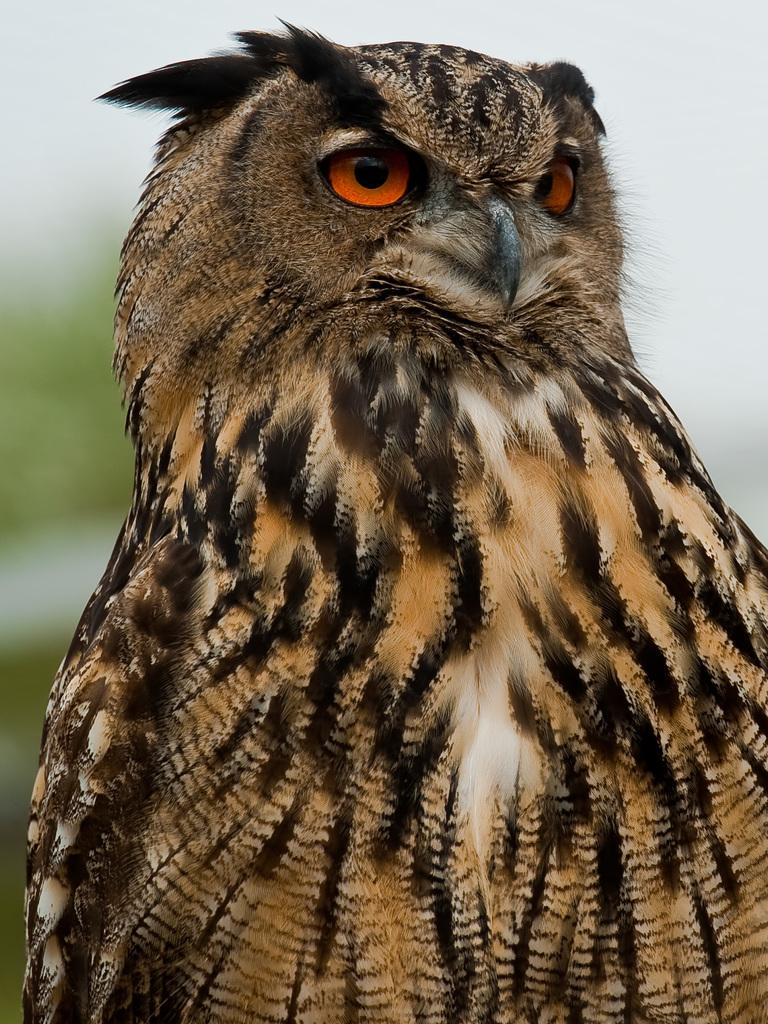What animal is the main subject of the image? There is an owl in the image. Where is the owl located in the image? The owl is in the middle of the image. What color is the owl? The owl is brown in color. What type of lumber is being used to build the carriage in the image? There is no carriage or lumber present in the image; it features an owl. How many coils are visible on the owl's body in the image? There are no coils visible on the owl's body in the image; it is a brown owl with no additional features mentioned. 